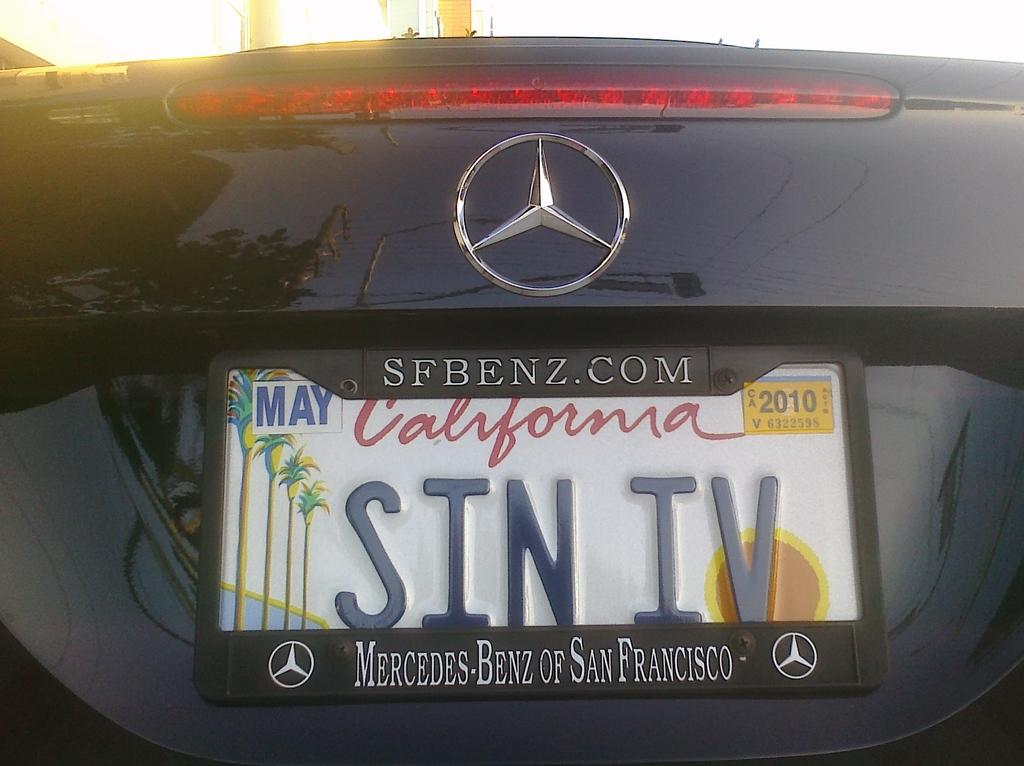<image>
Write a terse but informative summary of the picture. A mercedes benz branded back bumper with a license plate for california on it. 